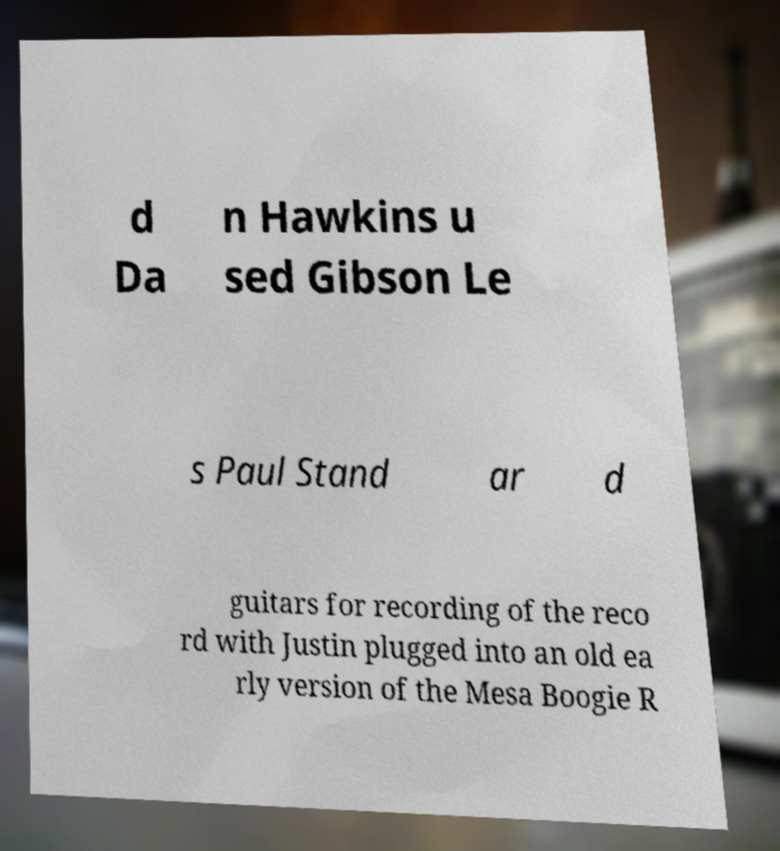For documentation purposes, I need the text within this image transcribed. Could you provide that? d Da n Hawkins u sed Gibson Le s Paul Stand ar d guitars for recording of the reco rd with Justin plugged into an old ea rly version of the Mesa Boogie R 